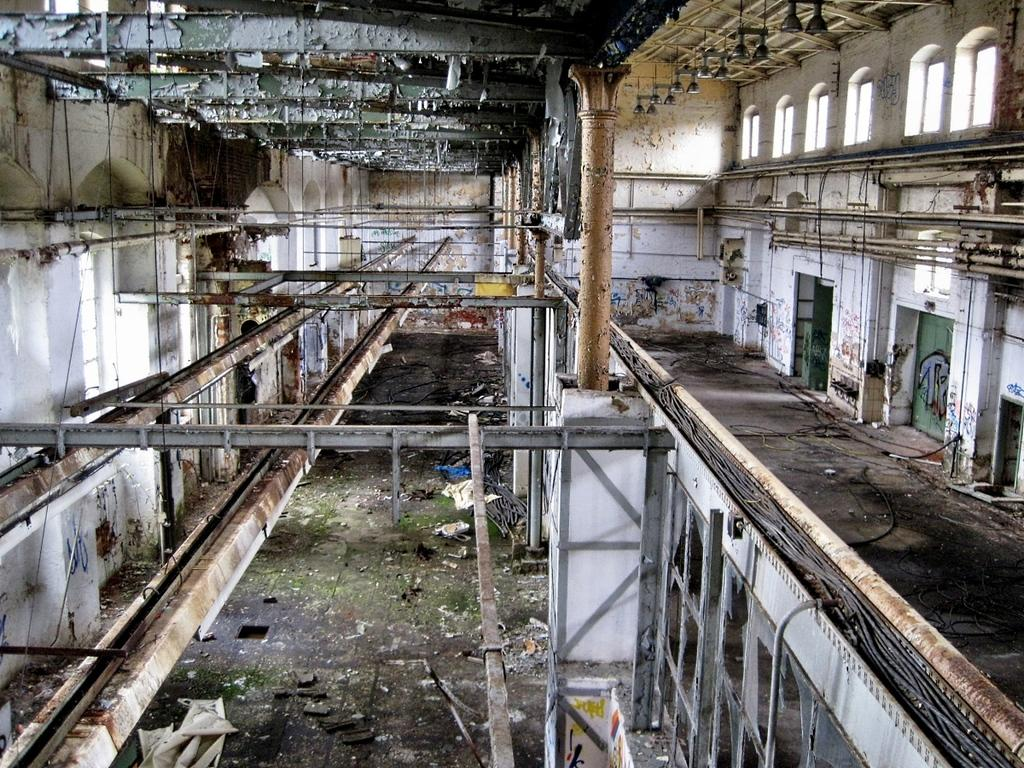What type of building is shown in the image? There is an old warehouse in the image. What is inside the warehouse? The warehouse contains scrap. What type of material can be seen inside the warehouse? Metal rods are present inside the warehouse. Are there any dogs playing in the grass outside the warehouse in the image? There is no grass or dogs present in the image; it shows an old warehouse containing scrap and metal rods. Can you see any signs of a protest happening near the warehouse in the image? There is no protest or any related signs visible in the image; it only shows the warehouse and its contents. 